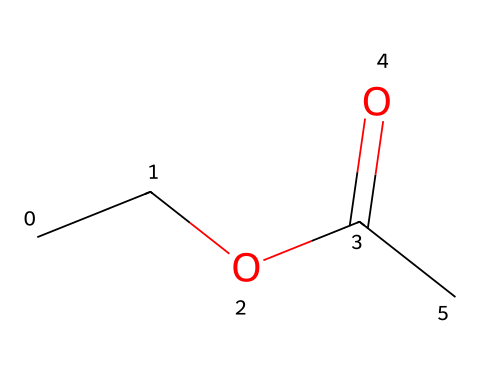how many carbon atoms are in ethyl acetate? Looking at the SMILES representation, we see the string "CC" at the beginning, which indicates two carbon atoms from the ethyl group. Additionally, there is one carbon in the carbonyl group (C=O) and one more following the carbonyl which is also a carbon. Thus, there are a total of 4 carbon atoms.
Answer: 4 what is the functional group present in ethyl acetate? In the SMILES representation, the section "C(=O)" illustrates a carbon atom double-bonded to an oxygen atom, characteristic of a carbonyl group. Additionally, as it is connected to an ethyl group, it forms an ester functional group turning this molecule into an ester.
Answer: ester how many oxygen atoms are present in ethyl acetate? If we analyze the SMILES string, we can see "O" appears twice: once in the carbonyl and once as part of the ester group. Thus, there are a total of 2 oxygen atoms in the structure.
Answer: 2 is ethyl acetate polar or non-polar? Ethyl acetate has a polar functional group (the carbonyl) and a non-polar alkyl group (the ethyl group). The presence of the polar carbonyl group gives the molecule overall polar characteristics, but it is not highly polar.
Answer: polar what type of solvents can dissolve ethyl acetate? Since ethyl acetate is relatively polar due to the carbonyl group and also contains a larger non-polar portion (ethyl), it mixes well with polar and some non-polar solvents. Typically, it can dissolve in alcohols and ketones well, as well as some hydrocarbons.
Answer: alcohols and ketones what is the primary use of ethyl acetate in the art world? Ethyl acetate is primarily used as a solvent, especially in acrylic paints and varnishes due to its ability to dissolve these components while offering a fast evaporation rate.
Answer: solvent 